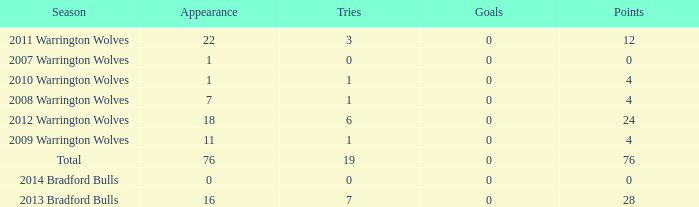What is the sum of appearance when goals is more than 0? None. 